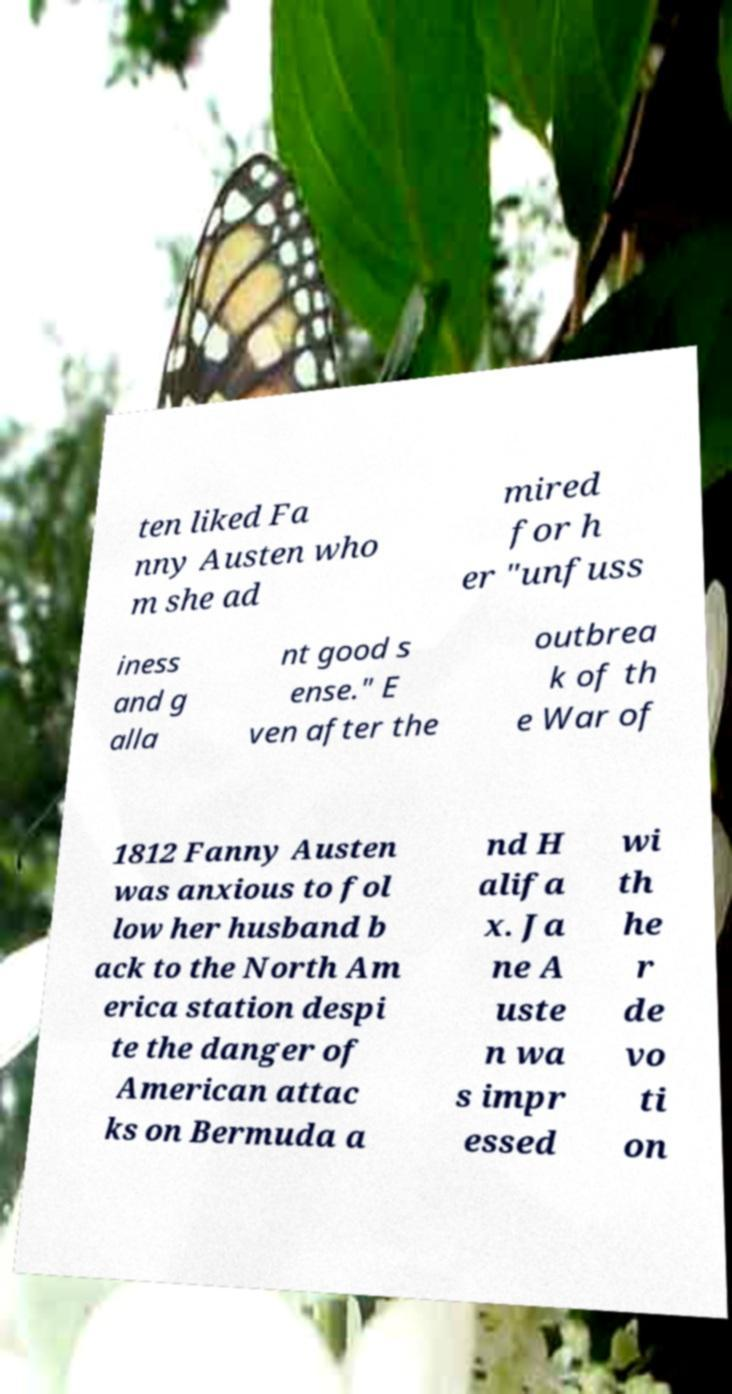Can you read and provide the text displayed in the image?This photo seems to have some interesting text. Can you extract and type it out for me? ten liked Fa nny Austen who m she ad mired for h er "unfuss iness and g alla nt good s ense." E ven after the outbrea k of th e War of 1812 Fanny Austen was anxious to fol low her husband b ack to the North Am erica station despi te the danger of American attac ks on Bermuda a nd H alifa x. Ja ne A uste n wa s impr essed wi th he r de vo ti on 